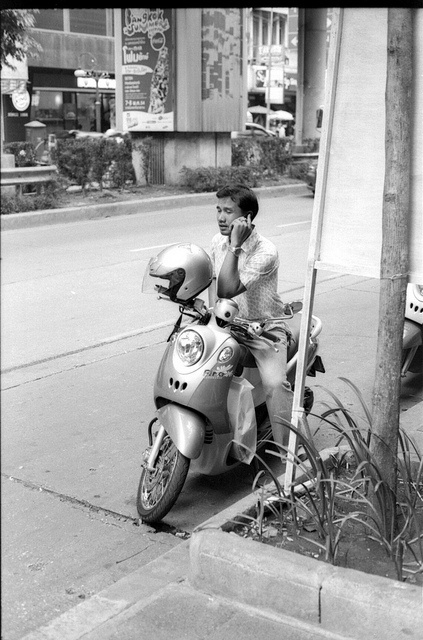Describe the objects in this image and their specific colors. I can see motorcycle in black, darkgray, gray, and lightgray tones, people in black, darkgray, gray, and lightgray tones, motorcycle in black, lightgray, gray, and darkgray tones, people in gray and black tones, and people in black, lightgray, darkgray, and gray tones in this image. 